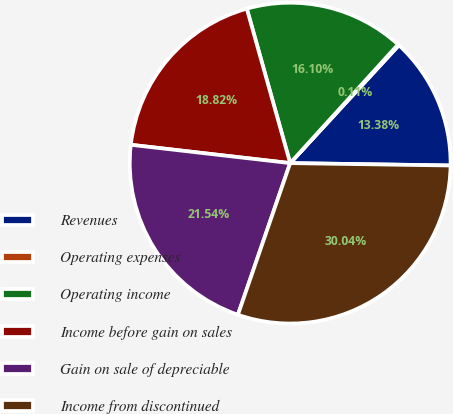<chart> <loc_0><loc_0><loc_500><loc_500><pie_chart><fcel>Revenues<fcel>Operating expenses<fcel>Operating income<fcel>Income before gain on sales<fcel>Gain on sale of depreciable<fcel>Income from discontinued<nl><fcel>13.38%<fcel>0.11%<fcel>16.1%<fcel>18.82%<fcel>21.54%<fcel>30.04%<nl></chart> 